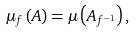<formula> <loc_0><loc_0><loc_500><loc_500>\mu _ { f } \left ( A \right ) = \mu \left ( A _ { f ^ { - 1 } } \right ) ,</formula> 